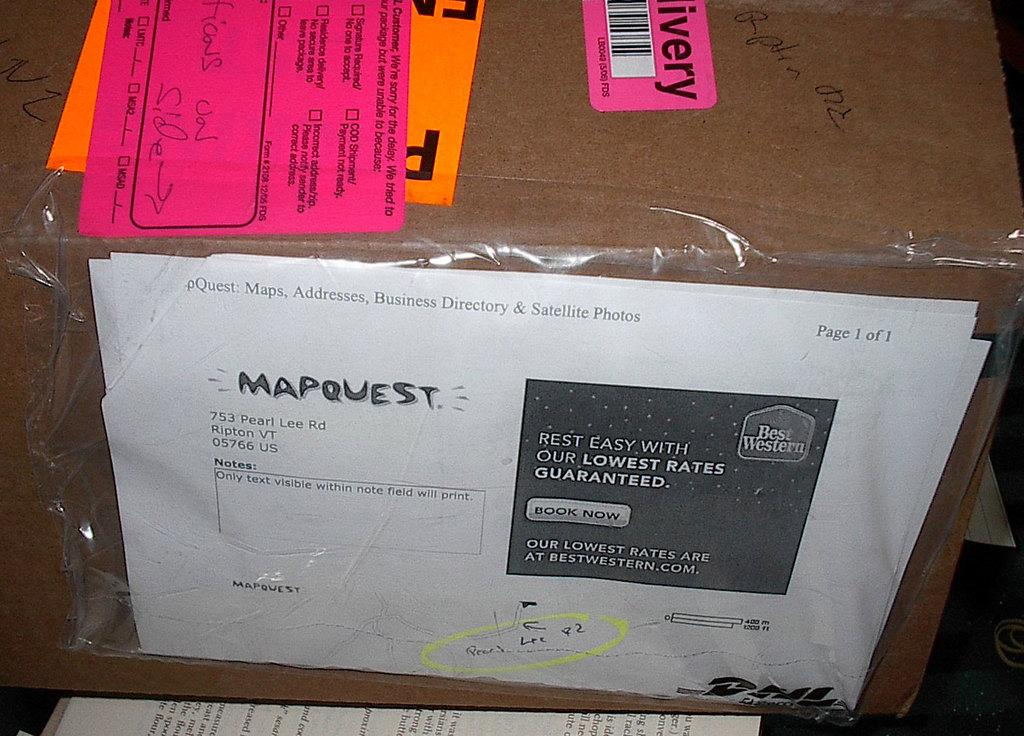What is the main object in the image? The main object in the image is a cardboard box. What is attached to the cardboard box? Papers are attached to the cardboard box. Are there any other papers visible in the image? Yes, there are additional papers under the box. How does the cardboard box rest on the papers? The cardboard box is not resting on the papers; it is standing upright. 